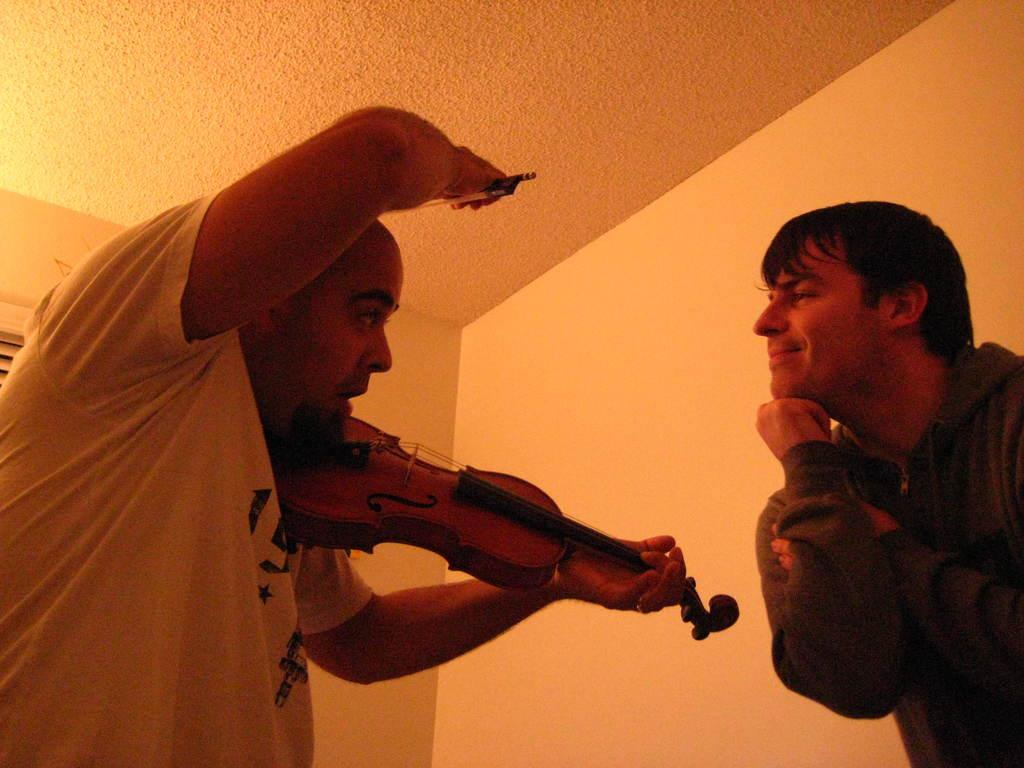What is the person on the left side of the image holding? The person on the left side of the image is holding a violin. What is the person on the right side of the image doing? The person on the right side of the image is standing. What can be seen in the background of the image? There is a wall in the background of the image. What type of pot is sitting on the head of the person on the right side of the image? There is no pot present on the head of the person on the right side of the image. What scientific theory is being discussed by the two people in the image? There is no indication of a scientific discussion or theory in the image. 